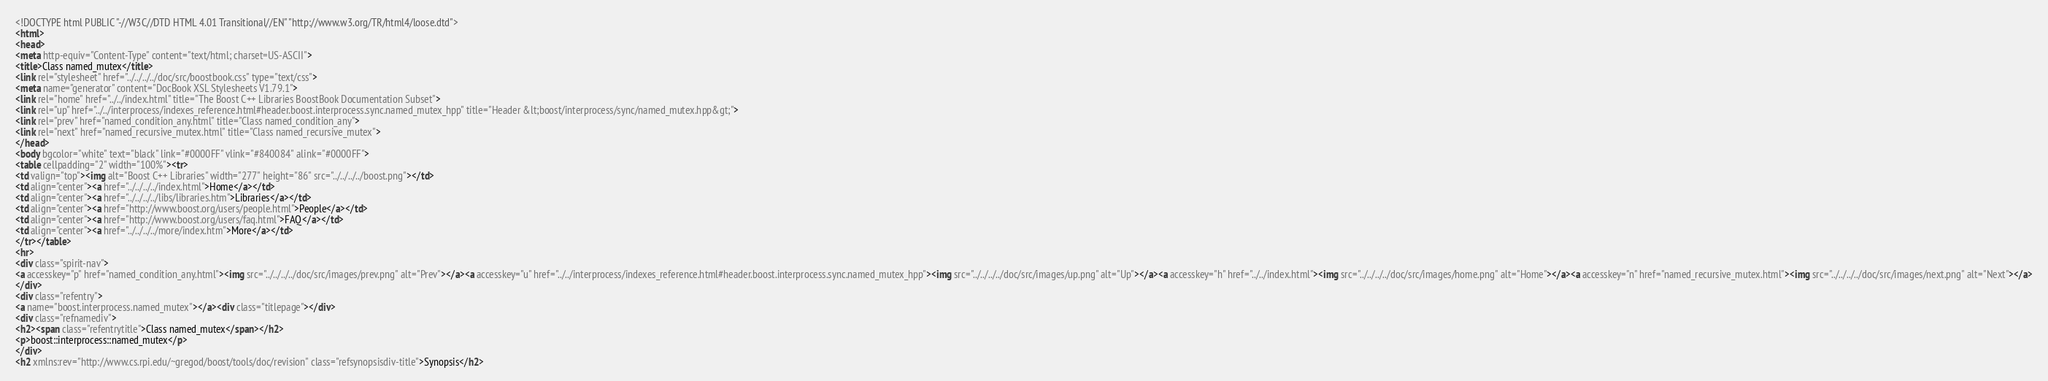<code> <loc_0><loc_0><loc_500><loc_500><_HTML_><!DOCTYPE html PUBLIC "-//W3C//DTD HTML 4.01 Transitional//EN" "http://www.w3.org/TR/html4/loose.dtd">
<html>
<head>
<meta http-equiv="Content-Type" content="text/html; charset=US-ASCII">
<title>Class named_mutex</title>
<link rel="stylesheet" href="../../../../doc/src/boostbook.css" type="text/css">
<meta name="generator" content="DocBook XSL Stylesheets V1.79.1">
<link rel="home" href="../../index.html" title="The Boost C++ Libraries BoostBook Documentation Subset">
<link rel="up" href="../../interprocess/indexes_reference.html#header.boost.interprocess.sync.named_mutex_hpp" title="Header &lt;boost/interprocess/sync/named_mutex.hpp&gt;">
<link rel="prev" href="named_condition_any.html" title="Class named_condition_any">
<link rel="next" href="named_recursive_mutex.html" title="Class named_recursive_mutex">
</head>
<body bgcolor="white" text="black" link="#0000FF" vlink="#840084" alink="#0000FF">
<table cellpadding="2" width="100%"><tr>
<td valign="top"><img alt="Boost C++ Libraries" width="277" height="86" src="../../../../boost.png"></td>
<td align="center"><a href="../../../../index.html">Home</a></td>
<td align="center"><a href="../../../../libs/libraries.htm">Libraries</a></td>
<td align="center"><a href="http://www.boost.org/users/people.html">People</a></td>
<td align="center"><a href="http://www.boost.org/users/faq.html">FAQ</a></td>
<td align="center"><a href="../../../../more/index.htm">More</a></td>
</tr></table>
<hr>
<div class="spirit-nav">
<a accesskey="p" href="named_condition_any.html"><img src="../../../../doc/src/images/prev.png" alt="Prev"></a><a accesskey="u" href="../../interprocess/indexes_reference.html#header.boost.interprocess.sync.named_mutex_hpp"><img src="../../../../doc/src/images/up.png" alt="Up"></a><a accesskey="h" href="../../index.html"><img src="../../../../doc/src/images/home.png" alt="Home"></a><a accesskey="n" href="named_recursive_mutex.html"><img src="../../../../doc/src/images/next.png" alt="Next"></a>
</div>
<div class="refentry">
<a name="boost.interprocess.named_mutex"></a><div class="titlepage"></div>
<div class="refnamediv">
<h2><span class="refentrytitle">Class named_mutex</span></h2>
<p>boost::interprocess::named_mutex</p>
</div>
<h2 xmlns:rev="http://www.cs.rpi.edu/~gregod/boost/tools/doc/revision" class="refsynopsisdiv-title">Synopsis</h2></code> 